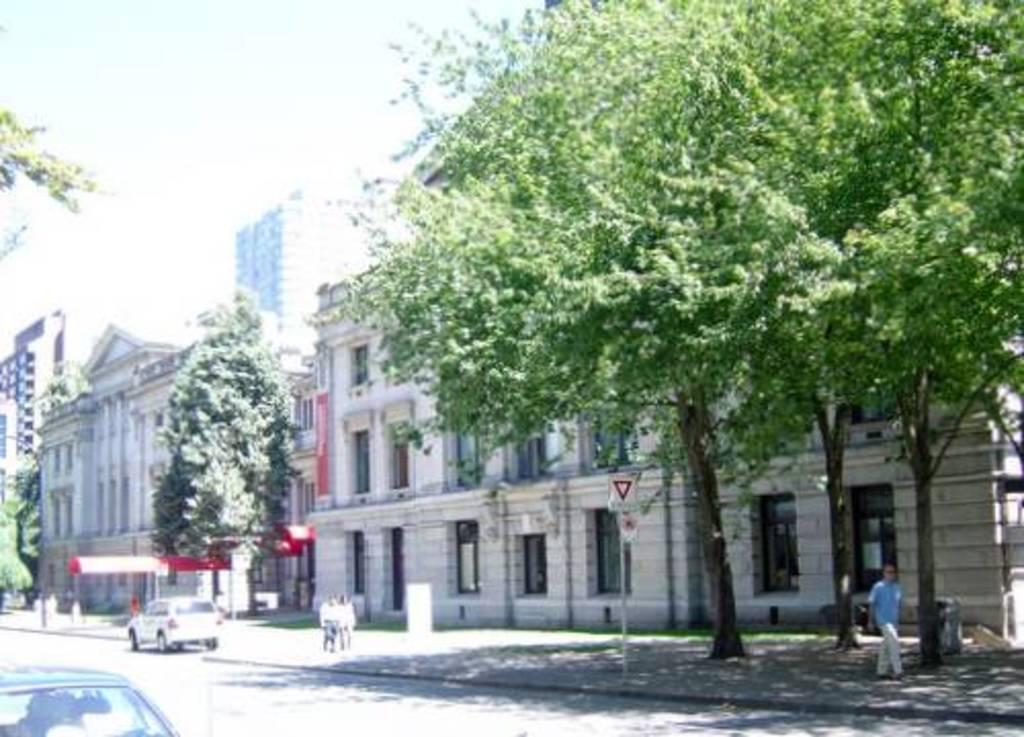Can you describe this image briefly? In this picture I can observe buildings in the middle of the picture. In front of the buildings there are trees. In the bottom of the picture I can observe road. In the background there is sky. 